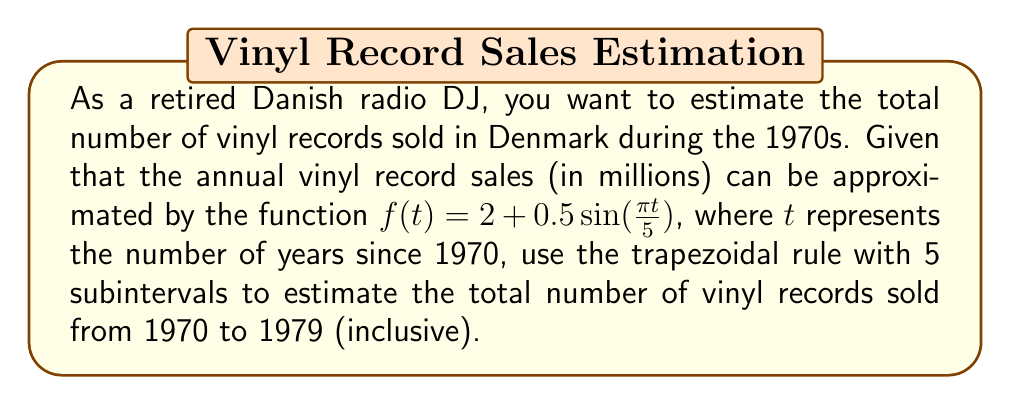Can you solve this math problem? 1) The integral we need to approximate is:
   $$\int_0^{10} f(t) dt = \int_0^{10} (2 + 0.5\sin(\frac{\pi t}{5})) dt$$

2) For the trapezoidal rule with 5 subintervals, we need to calculate:
   $$\Delta t = \frac{b-a}{n} = \frac{10-0}{5} = 2$$

3) We need to evaluate $f(t)$ at $t = 0, 2, 4, 6, 8,$ and $10$:
   
   $f(0) = 2 + 0.5\sin(0) = 2$
   $f(2) = 2 + 0.5\sin(\frac{2\pi}{5}) \approx 2.4755$
   $f(4) = 2 + 0.5\sin(\frac{4\pi}{5}) \approx 2.4755$
   $f(6) = 2 + 0.5\sin(\frac{6\pi}{5}) \approx 1.5245$
   $f(8) = 2 + 0.5\sin(\frac{8\pi}{5}) \approx 1.5245$
   $f(10) = 2 + 0.5\sin(2\pi) = 2$

4) Apply the trapezoidal rule:
   $$\int_0^{10} f(t) dt \approx \frac{\Delta t}{2}[f(0) + 2f(2) + 2f(4) + 2f(6) + 2f(8) + f(10)]$$
   
   $$\approx \frac{2}{2}[2 + 2(2.4755) + 2(2.4755) + 2(1.5245) + 2(1.5245) + 2]$$
   
   $$\approx 1[2 + 4.951 + 4.951 + 3.049 + 3.049 + 2]$$
   
   $$\approx 20$$

5) Therefore, the estimated total number of vinyl records sold in Denmark from 1970 to 1979 is approximately 20 million.
Answer: 20 million vinyl records 